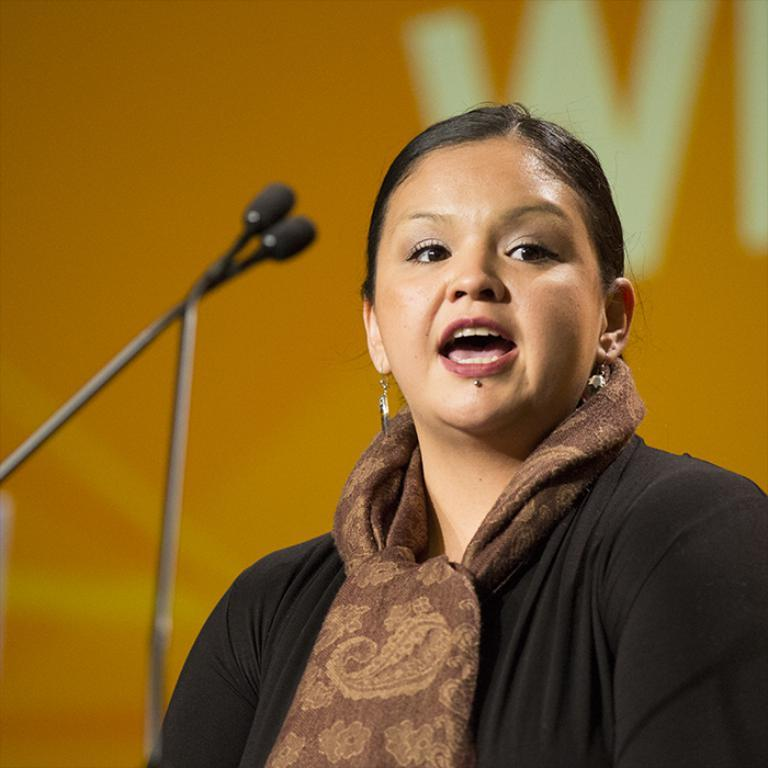What is the main subject in the foreground of the image? There is a woman standing in the foreground of the image. What is the woman doing in the image? The woman is standing in front of microphones. What can be seen in the background of the image? There appears to be a poster in the background of the image. How many friends can be seen in the image? There is no mention of friends in the image, as the focus is on the woman standing in front of microphones and the poster in the background. 